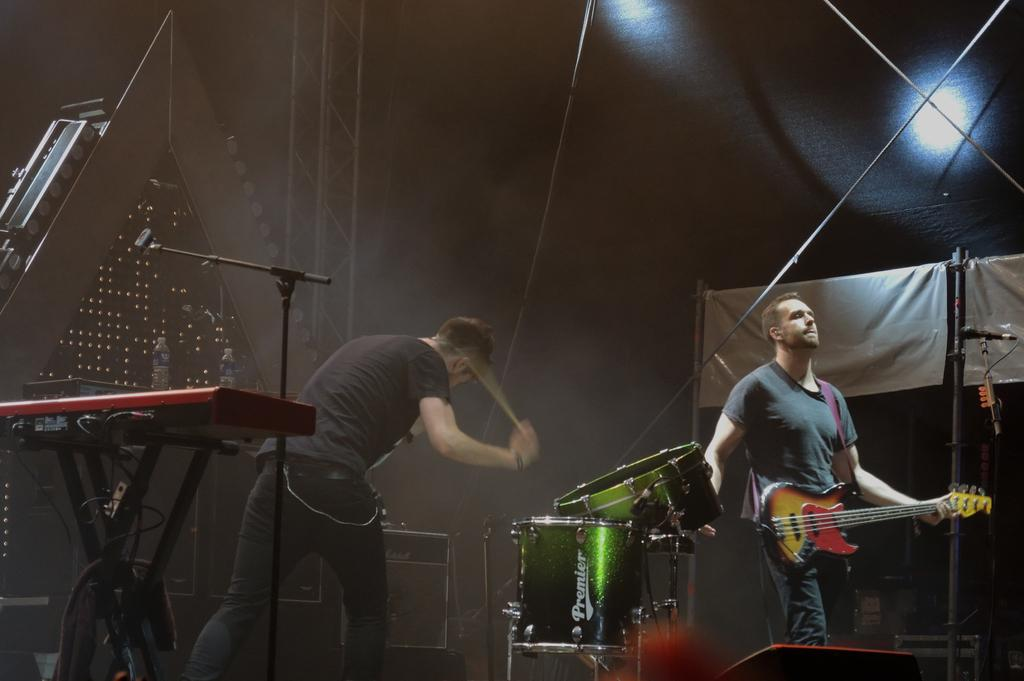How many people are in the image? There are two persons in the image. What is one person doing in the image? One person is holding a guitar. What is the same person also doing in the image? The same person is playing the drums. What can be seen in the background of the image? There is a water bottle and a light in the background. What type of string is being used to play the guitar in the image? There is no information about the type of string being used to play the guitar in the image. Can you see a tiger in the image? No, there is no tiger present in the image. 